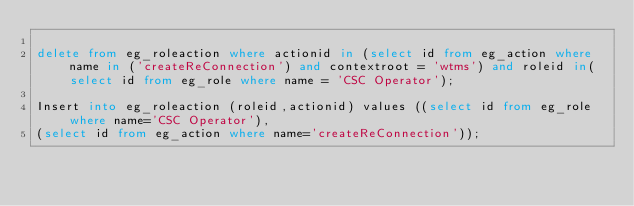Convert code to text. <code><loc_0><loc_0><loc_500><loc_500><_SQL_>
delete from eg_roleaction where actionid in (select id from eg_action where name in ('createReConnection') and contextroot = 'wtms') and roleid in(select id from eg_role where name = 'CSC Operator');

Insert into eg_roleaction (roleid,actionid) values ((select id from eg_role where name='CSC Operator'),
(select id from eg_action where name='createReConnection'));

</code> 